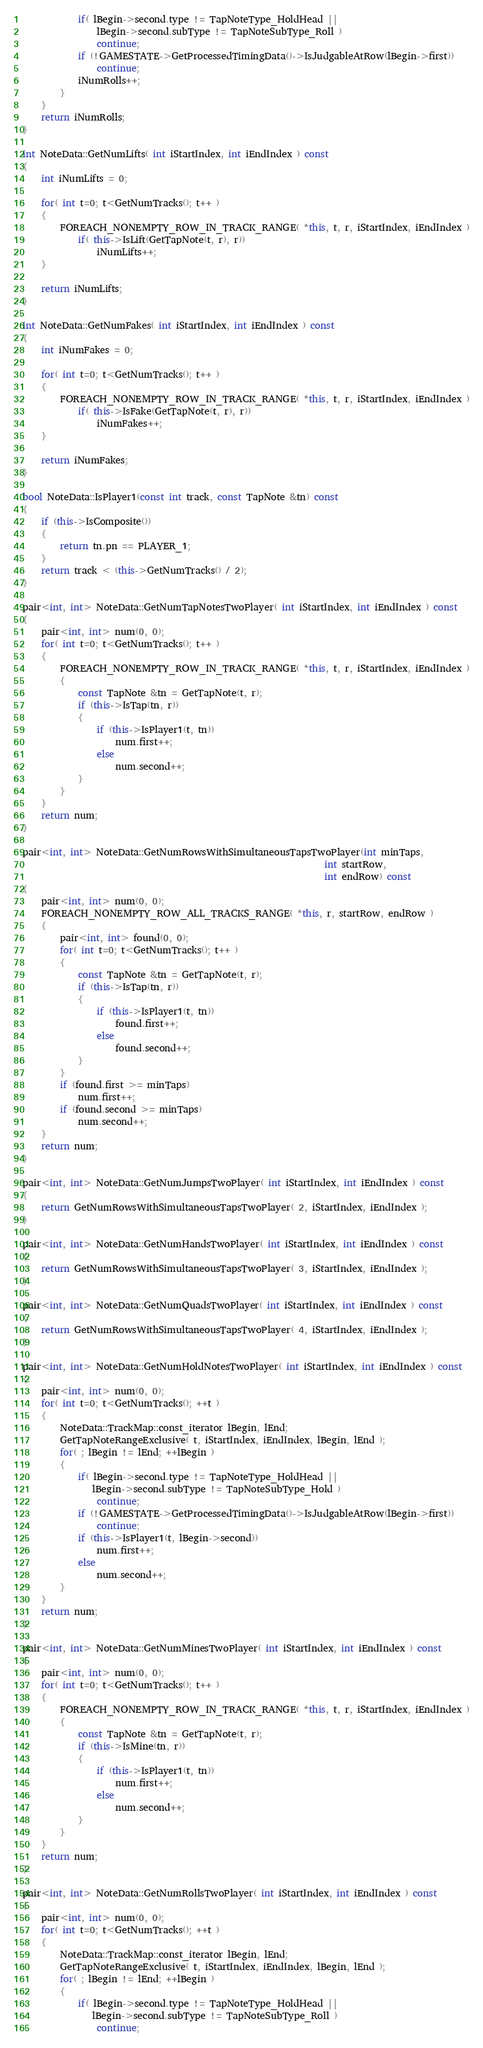<code> <loc_0><loc_0><loc_500><loc_500><_C++_>			if( lBegin->second.type != TapNoteType_HoldHead ||
				lBegin->second.subType != TapNoteSubType_Roll )
				continue;
			if (!GAMESTATE->GetProcessedTimingData()->IsJudgableAtRow(lBegin->first))
				continue;
			iNumRolls++;
		}
	}
	return iNumRolls;
}

int NoteData::GetNumLifts( int iStartIndex, int iEndIndex ) const
{
	int iNumLifts = 0;

	for( int t=0; t<GetNumTracks(); t++ )
	{
		FOREACH_NONEMPTY_ROW_IN_TRACK_RANGE( *this, t, r, iStartIndex, iEndIndex )
			if( this->IsLift(GetTapNote(t, r), r))
				iNumLifts++;
	}

	return iNumLifts;
}

int NoteData::GetNumFakes( int iStartIndex, int iEndIndex ) const
{
	int iNumFakes = 0;
	
	for( int t=0; t<GetNumTracks(); t++ )
	{
		FOREACH_NONEMPTY_ROW_IN_TRACK_RANGE( *this, t, r, iStartIndex, iEndIndex )
			if( this->IsFake(GetTapNote(t, r), r))
				iNumFakes++;
	}
	
	return iNumFakes;
}

bool NoteData::IsPlayer1(const int track, const TapNote &tn) const
{
	if (this->IsComposite())
	{
		return tn.pn == PLAYER_1;
	}
	return track < (this->GetNumTracks() / 2);
}

pair<int, int> NoteData::GetNumTapNotesTwoPlayer( int iStartIndex, int iEndIndex ) const
{
	pair<int, int> num(0, 0);
	for( int t=0; t<GetNumTracks(); t++ )
	{
		FOREACH_NONEMPTY_ROW_IN_TRACK_RANGE( *this, t, r, iStartIndex, iEndIndex )
		{
			const TapNote &tn = GetTapNote(t, r);
			if (this->IsTap(tn, r))
			{
				if (this->IsPlayer1(t, tn))
					num.first++;
				else
					num.second++;
			}
		}
	}
	return num;
}

pair<int, int> NoteData::GetNumRowsWithSimultaneousTapsTwoPlayer(int minTaps,
																 int startRow,
																 int endRow) const
{
	pair<int, int> num(0, 0);
	FOREACH_NONEMPTY_ROW_ALL_TRACKS_RANGE( *this, r, startRow, endRow )
	{
		pair<int, int> found(0, 0);
		for( int t=0; t<GetNumTracks(); t++ )
		{
			const TapNote &tn = GetTapNote(t, r);
			if (this->IsTap(tn, r))
			{
				if (this->IsPlayer1(t, tn))
					found.first++;
				else
					found.second++;
			}
		}
		if (found.first >= minTaps)
			num.first++;
		if (found.second >= minTaps)
			num.second++;
	}
	return num;
}

pair<int, int> NoteData::GetNumJumpsTwoPlayer( int iStartIndex, int iEndIndex ) const
{
	return GetNumRowsWithSimultaneousTapsTwoPlayer( 2, iStartIndex, iEndIndex );
}

pair<int, int> NoteData::GetNumHandsTwoPlayer( int iStartIndex, int iEndIndex ) const
{
	return GetNumRowsWithSimultaneousTapsTwoPlayer( 3, iStartIndex, iEndIndex );
}

pair<int, int> NoteData::GetNumQuadsTwoPlayer( int iStartIndex, int iEndIndex ) const
{
	return GetNumRowsWithSimultaneousTapsTwoPlayer( 4, iStartIndex, iEndIndex );
}

pair<int, int> NoteData::GetNumHoldNotesTwoPlayer( int iStartIndex, int iEndIndex ) const
{
	pair<int, int> num(0, 0);
	for( int t=0; t<GetNumTracks(); ++t )
	{
		NoteData::TrackMap::const_iterator lBegin, lEnd;
		GetTapNoteRangeExclusive( t, iStartIndex, iEndIndex, lBegin, lEnd );
		for( ; lBegin != lEnd; ++lBegin )
		{
			if( lBegin->second.type != TapNoteType_HoldHead ||
			   lBegin->second.subType != TapNoteSubType_Hold )
				continue;
			if (!GAMESTATE->GetProcessedTimingData()->IsJudgableAtRow(lBegin->first))
				continue;
			if (this->IsPlayer1(t, lBegin->second))
				num.first++;
			else
				num.second++;
		}
	}
	return num;
}

pair<int, int> NoteData::GetNumMinesTwoPlayer( int iStartIndex, int iEndIndex ) const
{
	pair<int, int> num(0, 0);
	for( int t=0; t<GetNumTracks(); t++ )
	{
		FOREACH_NONEMPTY_ROW_IN_TRACK_RANGE( *this, t, r, iStartIndex, iEndIndex )
		{
			const TapNote &tn = GetTapNote(t, r);
			if (this->IsMine(tn, r))
			{
				if (this->IsPlayer1(t, tn))
					num.first++;
				else
					num.second++;
			}
		}
	}
	return num;
}

pair<int, int> NoteData::GetNumRollsTwoPlayer( int iStartIndex, int iEndIndex ) const
{
	pair<int, int> num(0, 0);
	for( int t=0; t<GetNumTracks(); ++t )
	{
		NoteData::TrackMap::const_iterator lBegin, lEnd;
		GetTapNoteRangeExclusive( t, iStartIndex, iEndIndex, lBegin, lEnd );
		for( ; lBegin != lEnd; ++lBegin )
		{
			if( lBegin->second.type != TapNoteType_HoldHead ||
			   lBegin->second.subType != TapNoteSubType_Roll )
				continue;</code> 